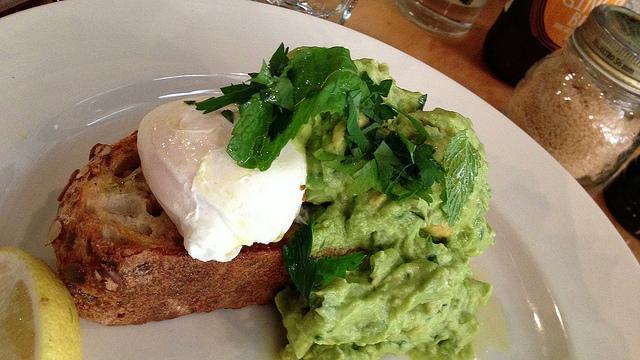How many bottles are there?
Give a very brief answer. 2. 